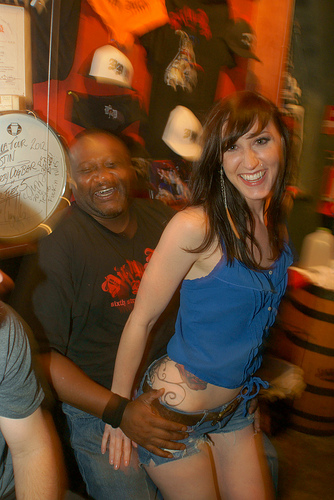<image>
Is the girl on the man? Yes. Looking at the image, I can see the girl is positioned on top of the man, with the man providing support. Is the girl above the man? Yes. The girl is positioned above the man in the vertical space, higher up in the scene. 